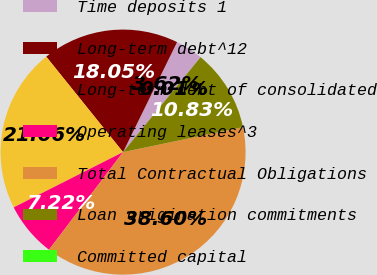Convert chart to OTSL. <chart><loc_0><loc_0><loc_500><loc_500><pie_chart><fcel>Time deposits 1<fcel>Long-term debt^12<fcel>Long-term debt of consolidated<fcel>Operating leases^3<fcel>Total Contractual Obligations<fcel>Loan origination commitments<fcel>Committed capital<nl><fcel>3.62%<fcel>18.05%<fcel>21.66%<fcel>7.22%<fcel>38.6%<fcel>10.83%<fcel>0.01%<nl></chart> 